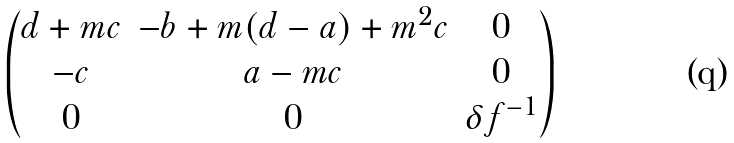Convert formula to latex. <formula><loc_0><loc_0><loc_500><loc_500>\begin{pmatrix} d + m c & - b + m ( d - a ) + m ^ { 2 } c & 0 \\ - c & a - m c & 0 \\ 0 & 0 & \delta f ^ { - 1 } \end{pmatrix}</formula> 